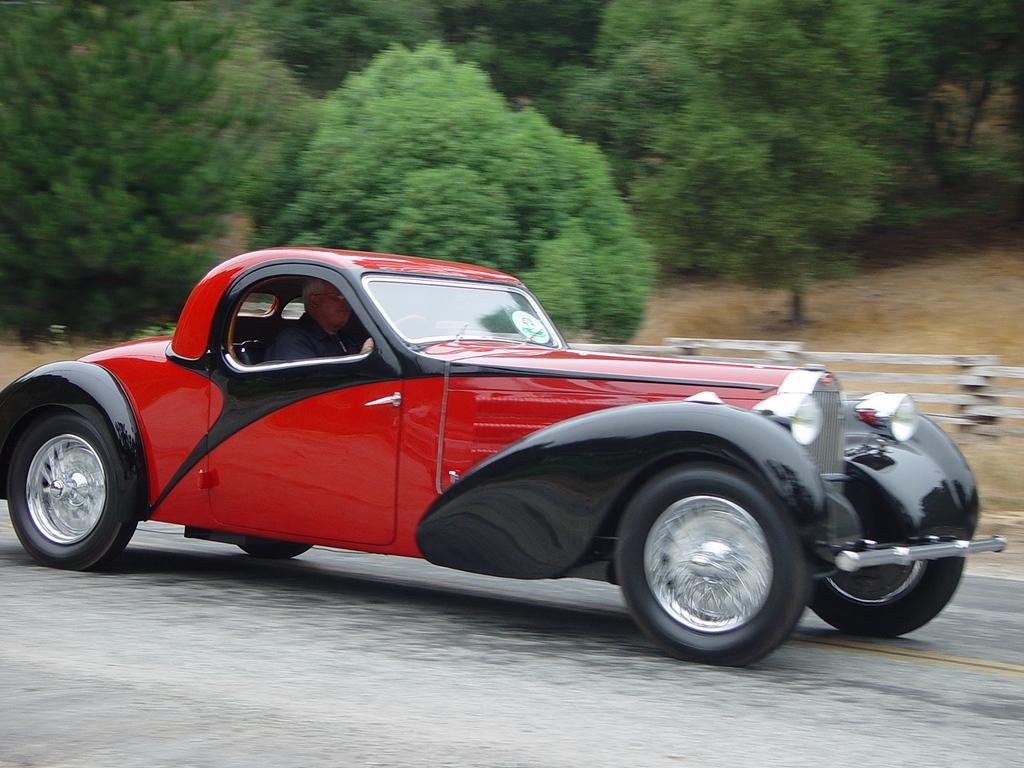What is parked on the road in the image? There is a car parked on the road in the image. Who is inside the car? A person is sitting in the car. What type of vegetation can be seen in the image? There are trees visible in the image. What type of fencing is present in the image? There is a wooden pole fencing in the image. What type of spark can be seen coming from the car's exhaust in the image? There is no spark coming from the car's exhaust in the image. What kind of pet is sitting next to the person in the car? There is no pet visible in the image. 